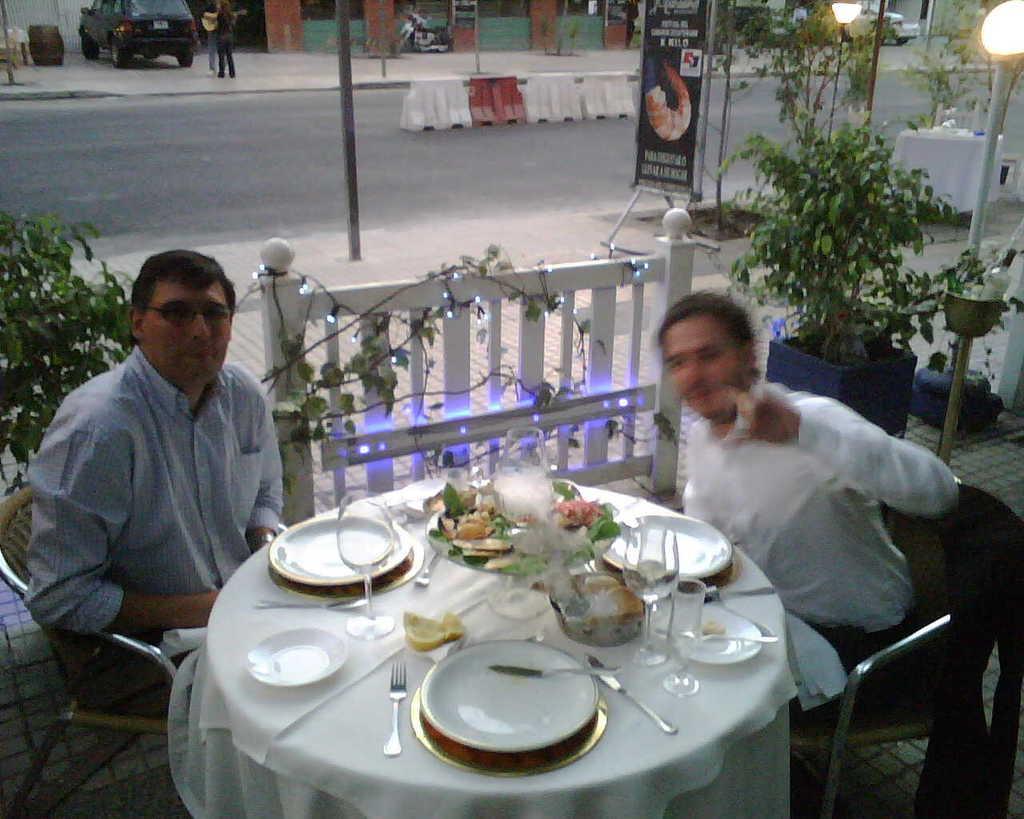How would you summarize this image in a sentence or two? There are two persons sitting in chairs and there is a white table in front of them which has plates,a glass of water and forks on it and there is a road beside them and there is a car,bike and a building in the background. 